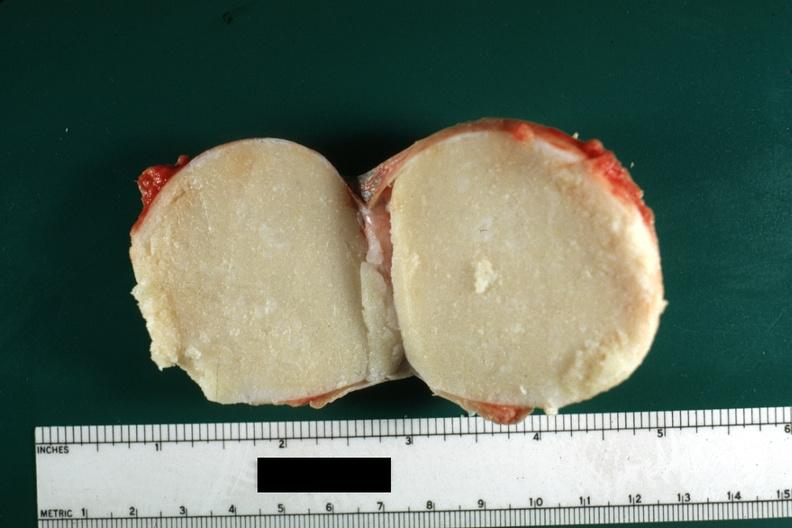was typical cheese like yellow content and thin fibrous capsule this lesion from the scrotal skin?
Answer the question using a single word or phrase. Yes 